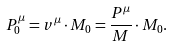Convert formula to latex. <formula><loc_0><loc_0><loc_500><loc_500>P ^ { \mu } _ { 0 } = v ^ { \mu } \cdot M _ { 0 } = \frac { P ^ { \mu } } { M } \cdot M _ { 0 } .</formula> 